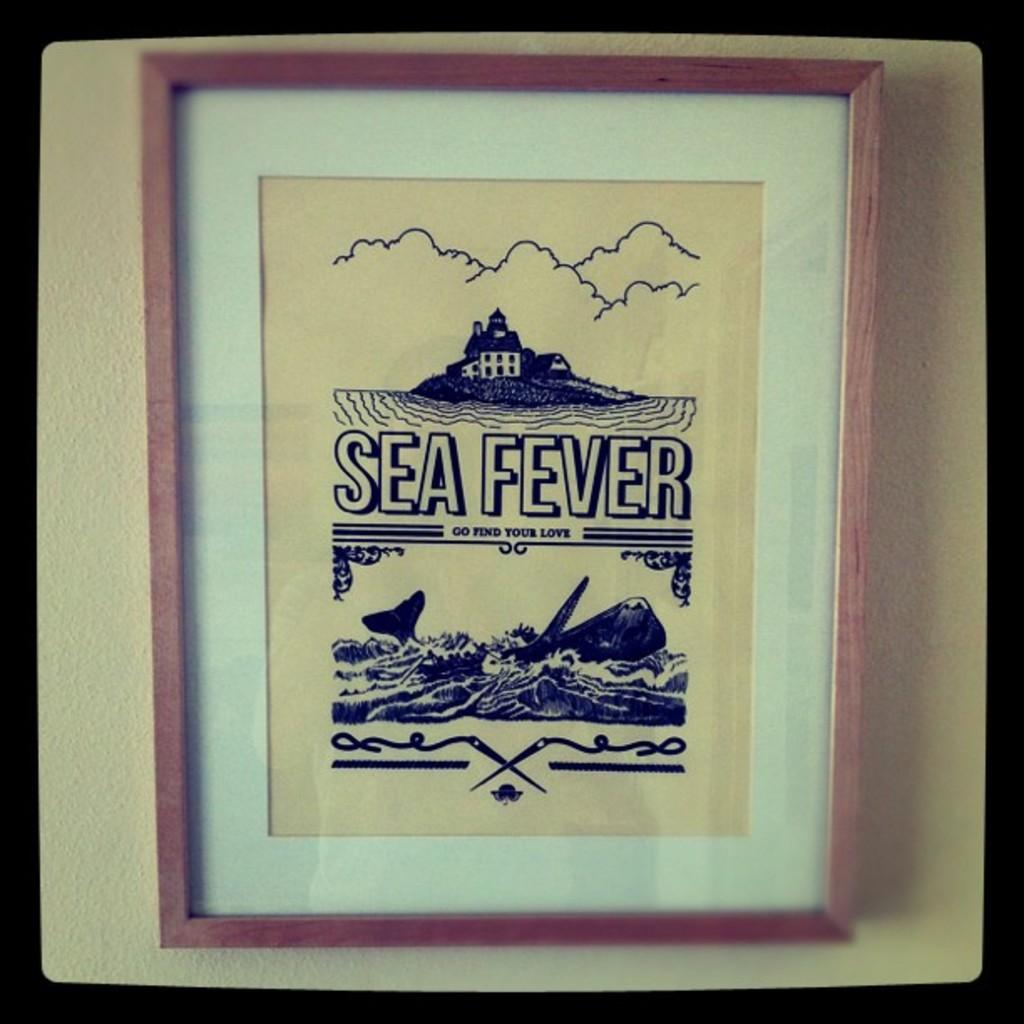<image>
Summarize the visual content of the image. Sea Fever Go Find Your Love picture in a frame. 